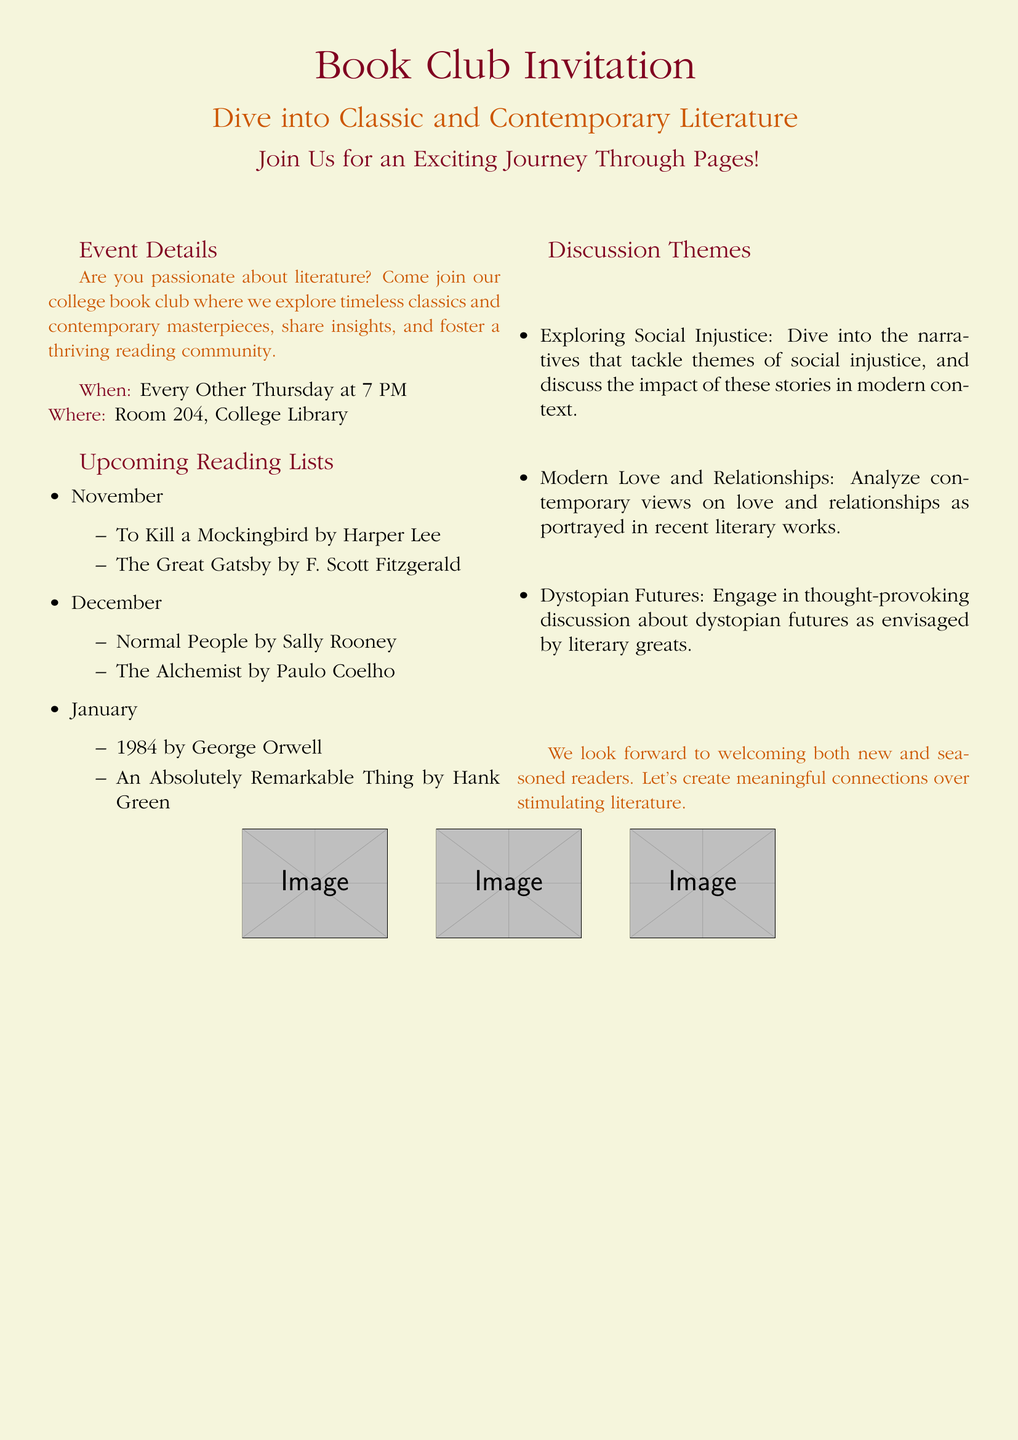What is the title of the event? The title of the event is prominently displayed at the top of the flyer.
Answer: Book Club Invitation What genre of literature will the book club explore? The flyer indicates the types of literature being explored in a descriptive phrase.
Answer: Classic and Contemporary Literature When does the book club meet? The schedule for the book club meetings is specified in the event details section.
Answer: Every Other Thursday at 7 PM Where is the book club held? The location for the meetings is provided clearly in the event details section.
Answer: Room 204, College Library What is one of the discussion themes listed for the book club? The discussion themes are outlined with labeled items in the respective section.
Answer: Exploring Social Injustice How many books are included in the November reading list? The number of books can be counted from the bullet points under the November section.
Answer: 2 Which author wrote "The Great Gatsby"? The author of the book included in the reading list for November is mentioned alongside the title.
Answer: F. Scott Fitzgerald What color is the background of the document? The document specifies a color for the background in the formatting section.
Answer: Soft beige What are the images depicted in the flyer? The images included in the flyer are described in a specific part of the document layout.
Answer: Open books, reading glasses, cozy nook 